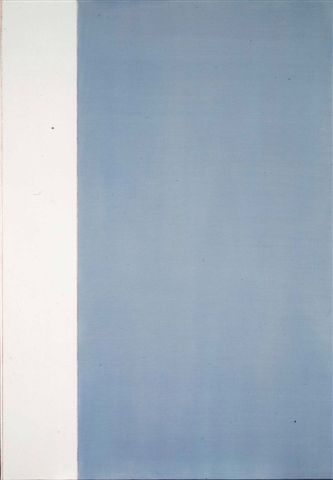If this artwork could tell a story, what would it be? If this artwork could tell a story, it might speak of a journey from simplicity to depth, from purity to complexity. The white section could symbolize a beginning, a blank slate where anything is possible. As one moves to the blue section, the gradient could represent the accumulation of experiences, knowledge, and emotions, illustrating the journey of life. The changing shades of blue might narrate the highs and lows, the light and dark moments that shape one's existence. Ultimately, the story could be about finding balance and harmony between these different states and embracing the full spectrum of the human experience. 